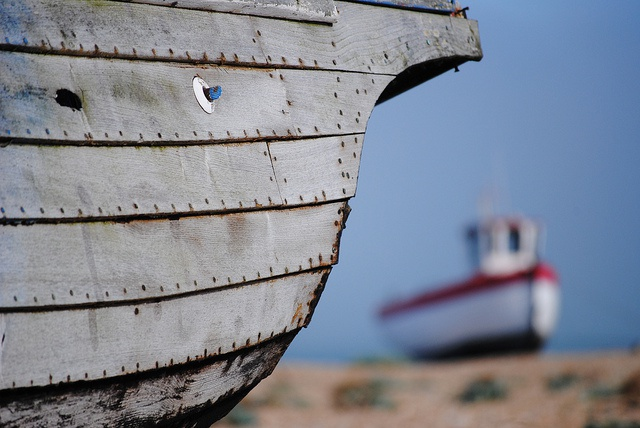Describe the objects in this image and their specific colors. I can see boat in gray, darkgray, black, and lightgray tones and boat in gray and darkgray tones in this image. 